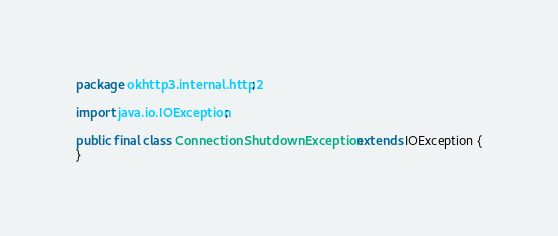<code> <loc_0><loc_0><loc_500><loc_500><_Java_>package okhttp3.internal.http2;

import java.io.IOException;

public final class ConnectionShutdownException extends IOException {
}
</code> 